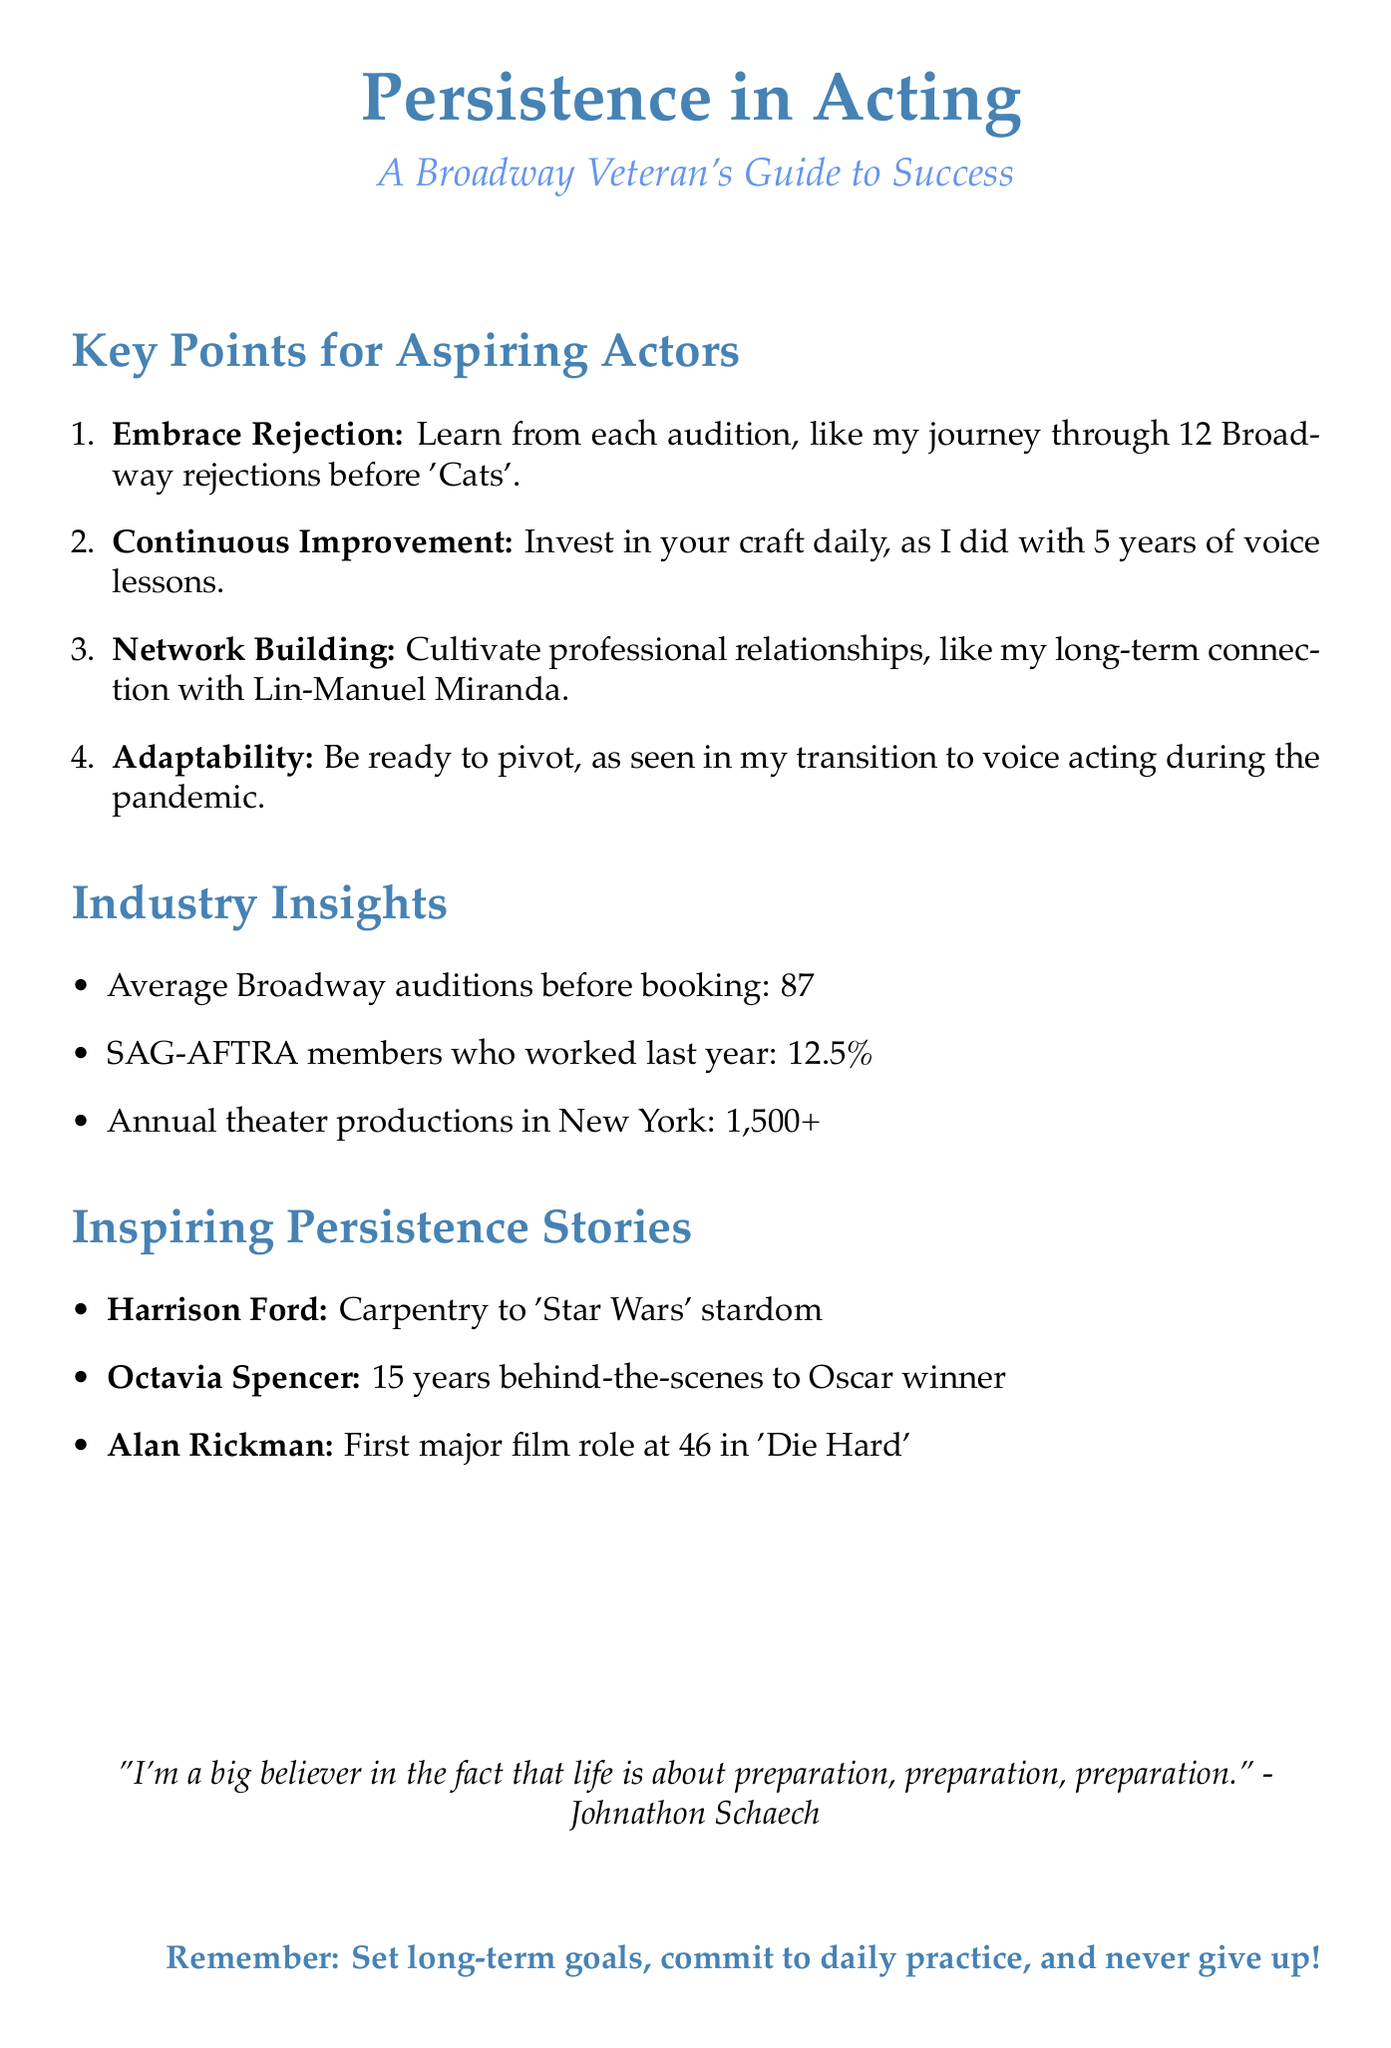What is the hook mentioned in the introduction? The hook is the story about Meryl Streep being rejected from a King Kong casting call.
Answer: Meryl Streep's rejection What is the thesis of the speech? The thesis states the main argument about persistence in acting careers.
Answer: Persistence is the cornerstone of a successful acting career How many auditions, on average, does it take to book a Broadway role? The document provides a statistic on the average number of auditions needed to book a role on Broadway.
Answer: 87 Which actor's persistence story involves working as a carpenter? The persistence story mentioned in the document includes Harrison Ford's background before his success.
Answer: Harrison Ford What long-term action does the conclusion encourage aspiring actors to take? The conclusion provides a call to action aimed at inspiring aspiring actors regarding their career development.
Answer: Set long-term goals What industry example illustrates continuous skill improvement? The document includes an example of a well-known actor who dedicated time to training for a role.
Answer: Hugh Jackman What notable role did Alan Rickman land at age 46? The document specifically states the role he achieved at this age, showcasing his persistence.
Answer: Die Hard What is the inspirational quote included in the conclusion? The conclusion wraps up the speech with a motivating quote about preparation by a notable figure.
Answer: "I'm a big believer in the fact that life is about preparation, preparation, preparation." - Johnathon Schaech 